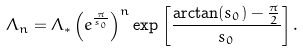Convert formula to latex. <formula><loc_0><loc_0><loc_500><loc_500>\Lambda _ { n } = \Lambda _ { * } \left ( e ^ { \frac { \pi } { s _ { 0 } } } \right ) ^ { n } \exp \left [ \frac { \arctan ( s _ { 0 } ) - \frac { \pi } { 2 } } { s _ { 0 } } \right ] .</formula> 